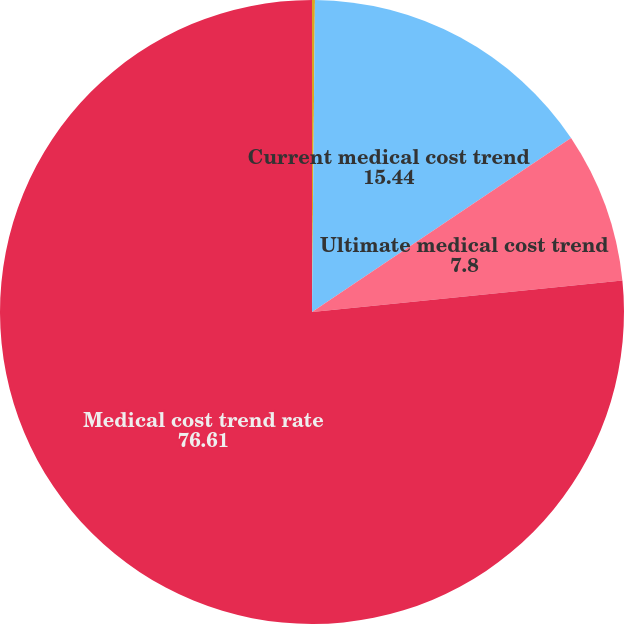Convert chart. <chart><loc_0><loc_0><loc_500><loc_500><pie_chart><fcel>Discount rate<fcel>Current medical cost trend<fcel>Ultimate medical cost trend<fcel>Medical cost trend rate<nl><fcel>0.15%<fcel>15.44%<fcel>7.8%<fcel>76.61%<nl></chart> 